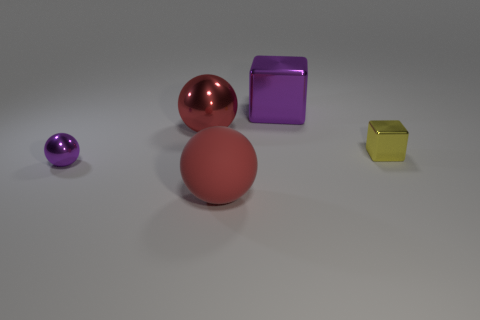What number of objects are behind the small ball and in front of the big red shiny object? Between the small purple ball and the large red shiny sphere, there is only one object directly aligned in this fashion, which is the yellow cube. 